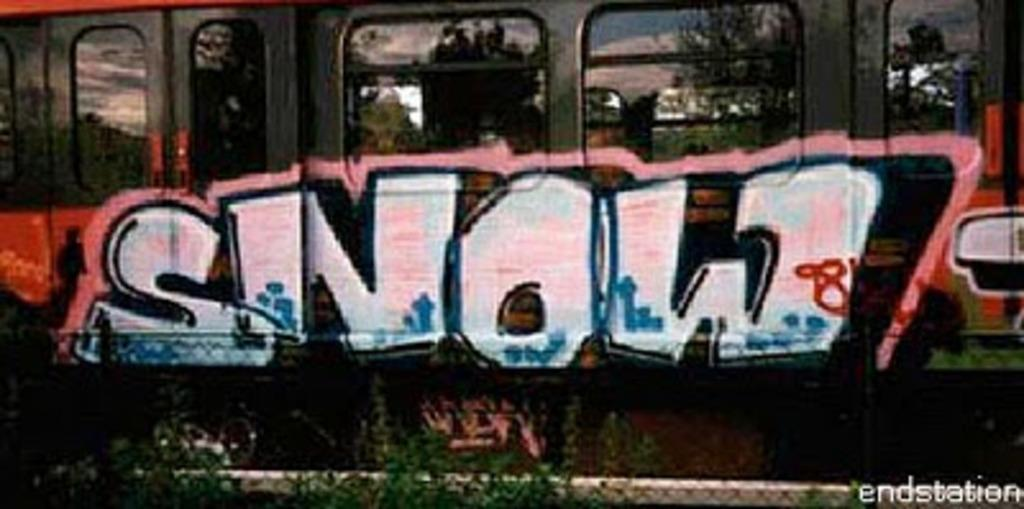<image>
Offer a succinct explanation of the picture presented. Grafitti drawn on a train which says "Snow". 